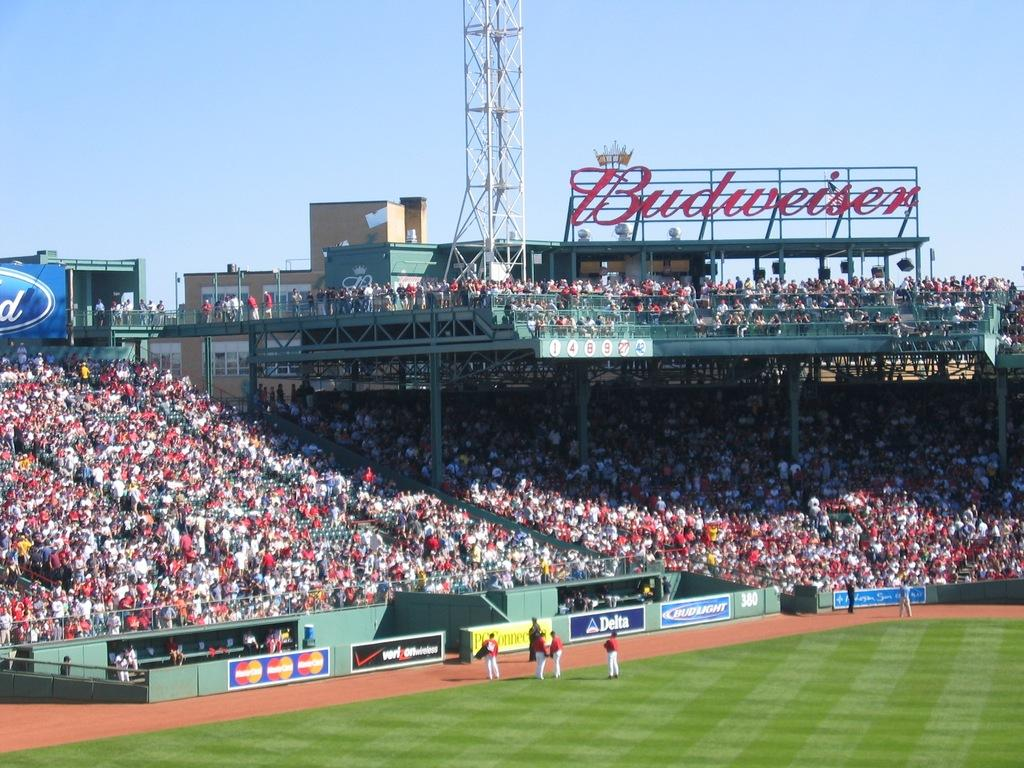Provide a one-sentence caption for the provided image. The stands are packed at a baseball stadium under a large billboard for Budweiser. 